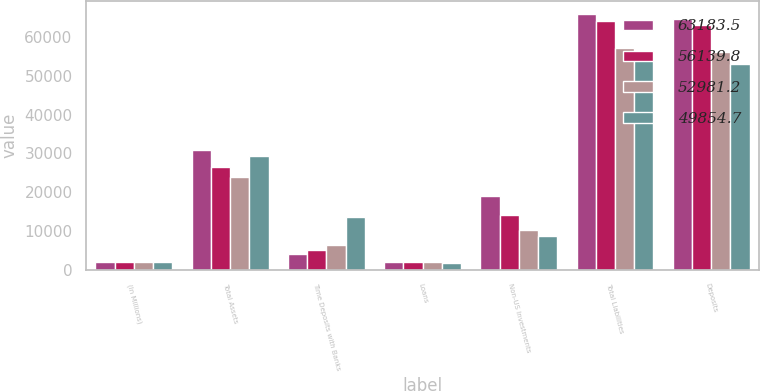Convert chart. <chart><loc_0><loc_0><loc_500><loc_500><stacked_bar_chart><ecel><fcel>(In Millions)<fcel>Total Assets<fcel>Time Deposits with Banks<fcel>Loans<fcel>Non-US Investments<fcel>Total Liabilities<fcel>Deposits<nl><fcel>63183.5<fcel>2018<fcel>30781.3<fcel>3943.2<fcel>2054.6<fcel>19016.1<fcel>66008.5<fcel>64721.6<nl><fcel>56139.8<fcel>2017<fcel>26510.1<fcel>5013.4<fcel>2014.8<fcel>14047.8<fcel>64267.3<fcel>63183.5<nl><fcel>52981.2<fcel>2016<fcel>24031<fcel>6331.3<fcel>1894.3<fcel>10255.7<fcel>57270<fcel>56139.8<nl><fcel>49854.7<fcel>2015<fcel>29411.2<fcel>13712.9<fcel>1759.4<fcel>8590.8<fcel>54521<fcel>52981.2<nl></chart> 